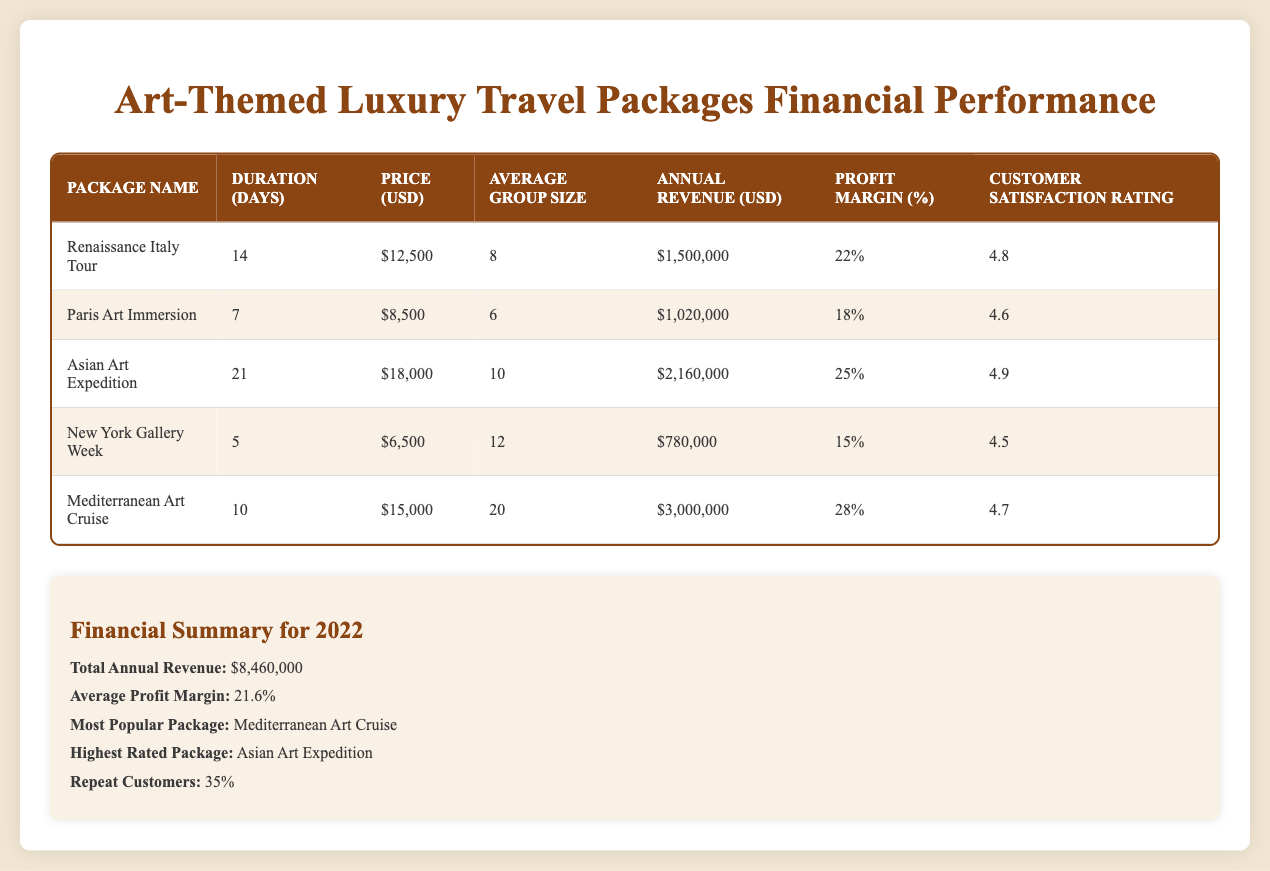What is the price of the "Asian Art Expedition" package? The price is listed in the “Price (USD)” column for the "Asian Art Expedition" row. It shows $18,000.
Answer: $18,000 Which package has the highest customer satisfaction rating? By examining the "Customer Satisfaction Rating" column, the highest rating is 4.9, which corresponds to the "Asian Art Expedition" package.
Answer: Asian Art Expedition What is the total revenue generated by the "Mediterranean Art Cruise"? The "Annual Revenue (USD)" column shows the revenue for the "Mediterranean Art Cruise" as $3,000,000.
Answer: $3,000,000 What is the average profit margin across all packages? The average profit margin is mentioned in the summary section. The table provides a value of 21.6%.
Answer: 21.6% Is the “Renaissance Italy Tour” package more profitable than the “Paris Art Immersion” package? The "Profit Margin (%)" for "Renaissance Italy Tour" is 22%, and for "Paris Art Immersion," it is 18%. Since 22% is greater than 18%, the "Renaissance Italy Tour" is more profitable.
Answer: Yes How many days does the "New York Gallery Week" package last? The duration is specified in the "Duration (Days)" column for the "New York Gallery Week" row, which indicates it lasts for 5 days.
Answer: 5 days What is the total annual revenue generated by all packages combined? The total is provided in the summary as $8,460,000, which includes the annual revenue from all individual packages.
Answer: $8,460,000 Which package is the most popular based on the provided data? According to the summary, the "Mediterranean Art Cruise" is noted as the most popular package.
Answer: Mediterranean Art Cruise How many customers on average attend the "Asian Art Expedition"? The “Average Group Size” column records 10 individuals for the "Asian Art Expedition" package.
Answer: 10 What percentage of customers are repeat customers? The summary indicates that 35% of customers are repeat customers.
Answer: 35% 